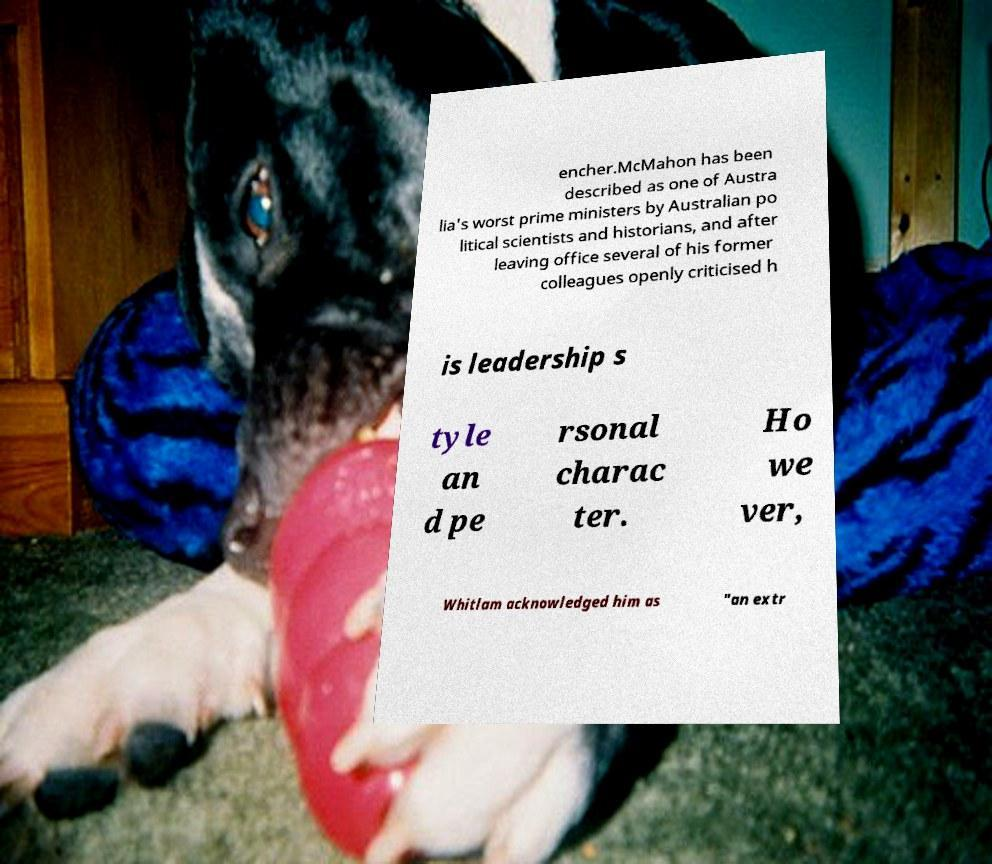Can you read and provide the text displayed in the image?This photo seems to have some interesting text. Can you extract and type it out for me? encher.McMahon has been described as one of Austra lia's worst prime ministers by Australian po litical scientists and historians, and after leaving office several of his former colleagues openly criticised h is leadership s tyle an d pe rsonal charac ter. Ho we ver, Whitlam acknowledged him as "an extr 